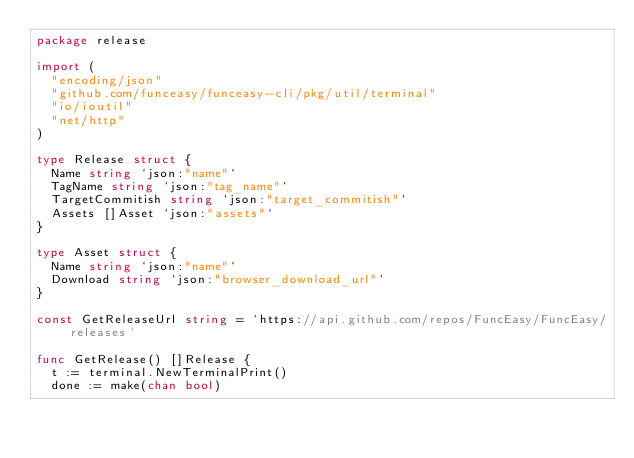Convert code to text. <code><loc_0><loc_0><loc_500><loc_500><_Go_>package release

import (
	"encoding/json"
	"github.com/funceasy/funceasy-cli/pkg/util/terminal"
	"io/ioutil"
	"net/http"
)

type Release struct {
	Name string `json:"name"`
	TagName string `json:"tag_name"`
	TargetCommitish string `json:"target_commitish"`
	Assets []Asset `json:"assets"`
}

type Asset struct {
	Name string `json:"name"`
	Download string `json:"browser_download_url"`
}

const GetReleaseUrl string = `https://api.github.com/repos/FuncEasy/FuncEasy/releases`

func GetRelease() []Release {
	t := terminal.NewTerminalPrint()
	done := make(chan bool)</code> 